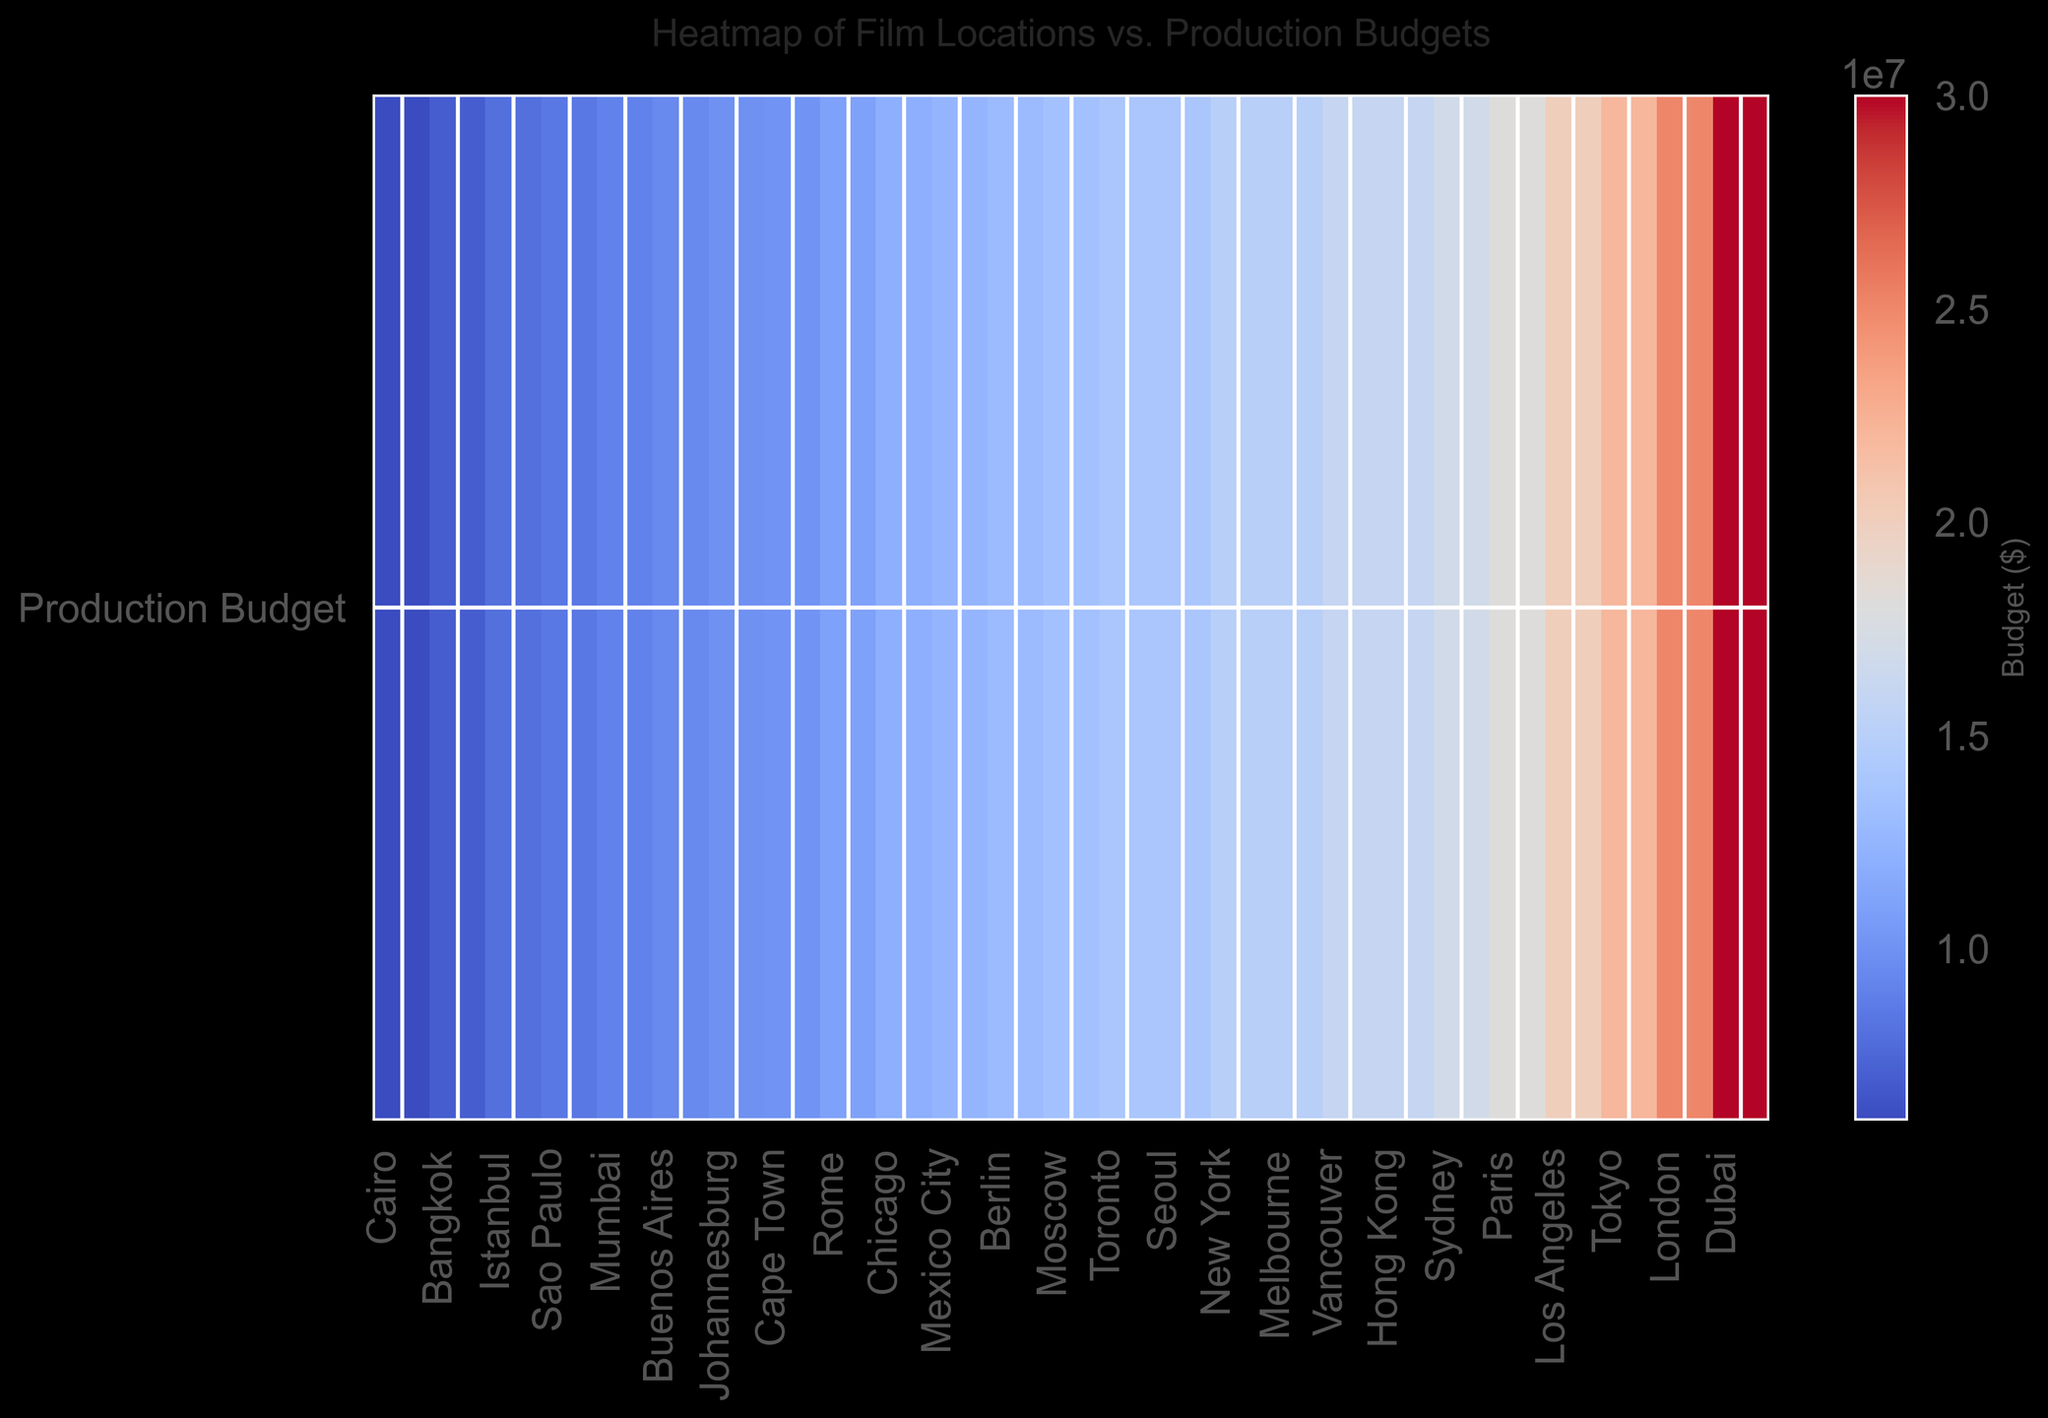Which location has the highest production budget? Looking at the heatmap's color gradient, the brightest color represents the highest budget. Dubai is the location with the brightest shade, indicating it has the highest production budget.
Answer: Dubai Which location has the lowest production budget? The heatmap shows the darkest shade for the lowest budget. Cairo is the location with the darkest shade.
Answer: Cairo Which location has a higher production budget, Toronto or Melbourne? The heatmap shows shades indicating budgets. Melbourne's shade is lighter than Toronto's, meaning Melbourne has a higher budget.
Answer: Melbourne What is the average production budget for films in Rome, Cairo, and Mexico City? Locate the shades for Rome, Cairo, and Mexico City. Convert their visual shades to numerical budgets: $11,000,000 (Rome), $6,000,000 (Cairo), and $12,500,000 (Mexico City). The total is $29,500,000, averaging: $29,500,000 / 3 = $9,833,333.33.
Answer: $9,833,333.33 Which city, Tokyo or Berlin, has a higher production budget? Compare their shades; Tokyo's is lighter than Berlin's. Hence Tokyo has a higher budget.
Answer: Tokyo What is the difference in production budget between Paris and Mumbai? Identify the shades corresponding to their budgets: $18,000,000 (Paris) and $9,000,000 (Mumbai). Subtract Mumbai's budget from Paris's: $18,000,000 - $9,000,000 = $9,000,000.
Answer: $9,000,000 Is the production budget of Sydney higher or lower than that of New York? Compare their shades; Sydney's is lighter than New York's. Thus, Sydney has a higher budget.
Answer: Higher Rank the following locations by production budget from highest to lowest: Seoul, Istanbul, Moscow. Compare shades for Seoul, Istanbul, and Moscow: $14,000,000 (Seoul), $8,000,000 (Istanbul), $13,500,000 (Moscow). The order: Seoul, Moscow, Istanbul.
Answer: Seoul, Moscow, Istanbul Can you identify if any locations have the same production budget? Check if any locations share the exact same shade. New York and Melbourne both have the same shade, indicating a budget of $15,000,000.
Answer: New York, Melbourne 